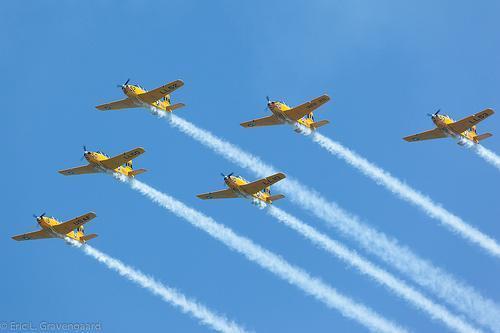How many planes are shown?
Give a very brief answer. 6. How many airplane are falling down to the ground?
Give a very brief answer. 0. 